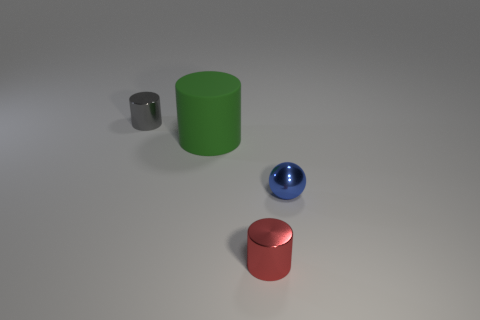Are there any metallic objects to the left of the tiny red thing that is in front of the sphere?
Offer a very short reply. Yes. What number of blocks are either large yellow matte things or tiny things?
Your answer should be compact. 0. There is a shiny object on the left side of the tiny cylinder that is in front of the thing left of the big green thing; what size is it?
Provide a succinct answer. Small. There is a blue sphere; are there any shiny objects in front of it?
Provide a short and direct response. Yes. How many objects are small blue objects in front of the green cylinder or big red rubber cylinders?
Give a very brief answer. 1. There is a red object that is made of the same material as the gray cylinder; what size is it?
Your answer should be compact. Small. There is a green rubber cylinder; is its size the same as the shiny cylinder that is to the right of the gray cylinder?
Your answer should be very brief. No. What color is the metal object that is in front of the big matte cylinder and left of the metallic sphere?
Ensure brevity in your answer.  Red. How many objects are metal cylinders to the right of the gray metallic object or things that are in front of the big green matte cylinder?
Your answer should be very brief. 2. The metal thing right of the metal cylinder that is in front of the small metallic cylinder that is behind the blue sphere is what color?
Ensure brevity in your answer.  Blue. 